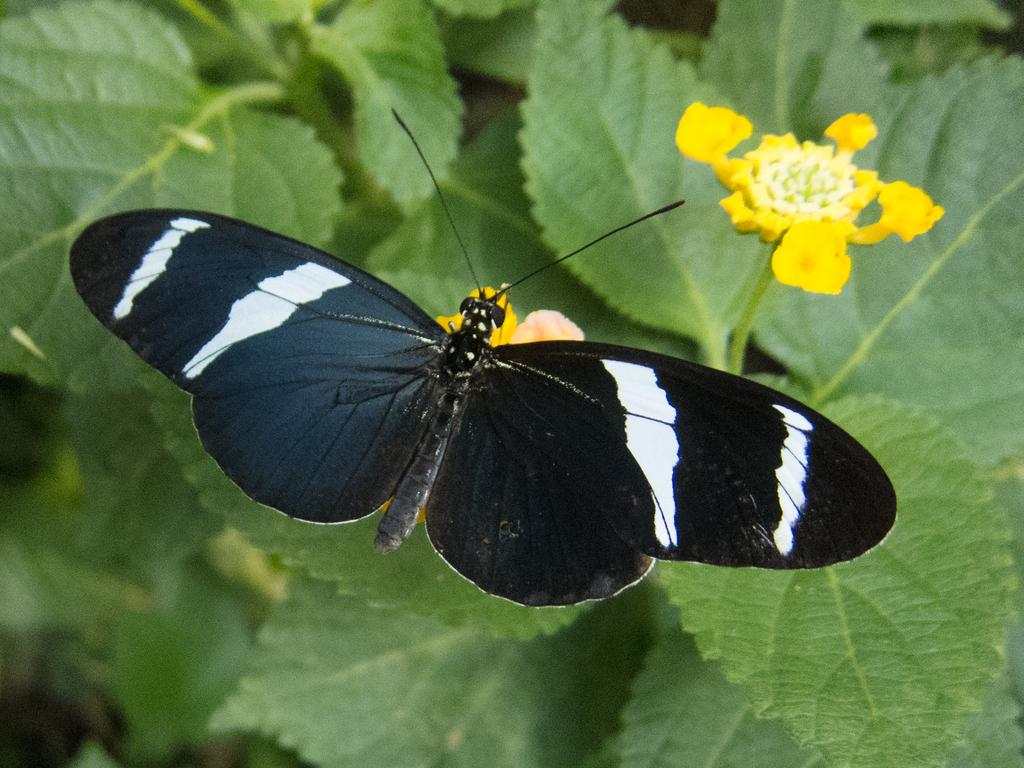What is the main subject of the image? There is a butterfly in the image. Where is the butterfly located? The butterfly is on a flower. What colors can be seen on the butterfly? The butterfly has white and black colors. What type of flowers are in the image? There are yellow and white flowers in the image. Are the flowers attached to any plants? Yes, the flowers are on plants. Can you tell me how many beads are hanging from the butterfly's wings in the image? There are no beads hanging from the butterfly's wings in the image. Is there a mask visible on the butterfly in the image? There is no mask present on the butterfly in the image. 